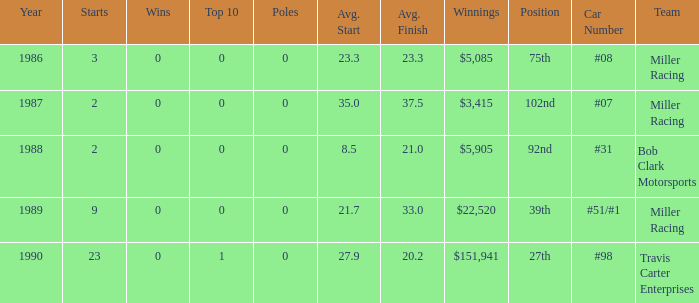What racing team/s had the 92nd position? #31 Bob Clark Motorsports. 